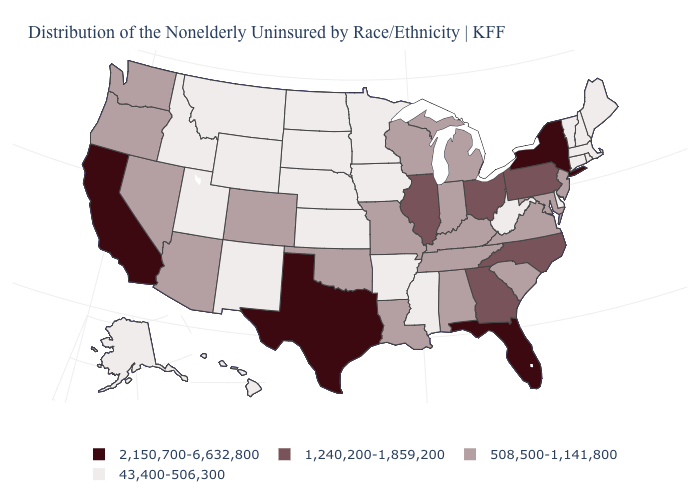Name the states that have a value in the range 508,500-1,141,800?
Quick response, please. Alabama, Arizona, Colorado, Indiana, Kentucky, Louisiana, Maryland, Michigan, Missouri, Nevada, New Jersey, Oklahoma, Oregon, South Carolina, Tennessee, Virginia, Washington, Wisconsin. Name the states that have a value in the range 43,400-506,300?
Answer briefly. Alaska, Arkansas, Connecticut, Delaware, Hawaii, Idaho, Iowa, Kansas, Maine, Massachusetts, Minnesota, Mississippi, Montana, Nebraska, New Hampshire, New Mexico, North Dakota, Rhode Island, South Dakota, Utah, Vermont, West Virginia, Wyoming. Name the states that have a value in the range 508,500-1,141,800?
Concise answer only. Alabama, Arizona, Colorado, Indiana, Kentucky, Louisiana, Maryland, Michigan, Missouri, Nevada, New Jersey, Oklahoma, Oregon, South Carolina, Tennessee, Virginia, Washington, Wisconsin. Does Missouri have the same value as New Jersey?
Give a very brief answer. Yes. Name the states that have a value in the range 1,240,200-1,859,200?
Write a very short answer. Georgia, Illinois, North Carolina, Ohio, Pennsylvania. What is the highest value in the West ?
Concise answer only. 2,150,700-6,632,800. What is the value of Nevada?
Concise answer only. 508,500-1,141,800. Which states have the lowest value in the USA?
Answer briefly. Alaska, Arkansas, Connecticut, Delaware, Hawaii, Idaho, Iowa, Kansas, Maine, Massachusetts, Minnesota, Mississippi, Montana, Nebraska, New Hampshire, New Mexico, North Dakota, Rhode Island, South Dakota, Utah, Vermont, West Virginia, Wyoming. Among the states that border West Virginia , does Ohio have the lowest value?
Write a very short answer. No. Name the states that have a value in the range 43,400-506,300?
Give a very brief answer. Alaska, Arkansas, Connecticut, Delaware, Hawaii, Idaho, Iowa, Kansas, Maine, Massachusetts, Minnesota, Mississippi, Montana, Nebraska, New Hampshire, New Mexico, North Dakota, Rhode Island, South Dakota, Utah, Vermont, West Virginia, Wyoming. Does Michigan have a higher value than Iowa?
Concise answer only. Yes. Does the map have missing data?
Be succinct. No. Does West Virginia have a lower value than Missouri?
Concise answer only. Yes. Name the states that have a value in the range 43,400-506,300?
Answer briefly. Alaska, Arkansas, Connecticut, Delaware, Hawaii, Idaho, Iowa, Kansas, Maine, Massachusetts, Minnesota, Mississippi, Montana, Nebraska, New Hampshire, New Mexico, North Dakota, Rhode Island, South Dakota, Utah, Vermont, West Virginia, Wyoming. What is the lowest value in the USA?
Give a very brief answer. 43,400-506,300. 